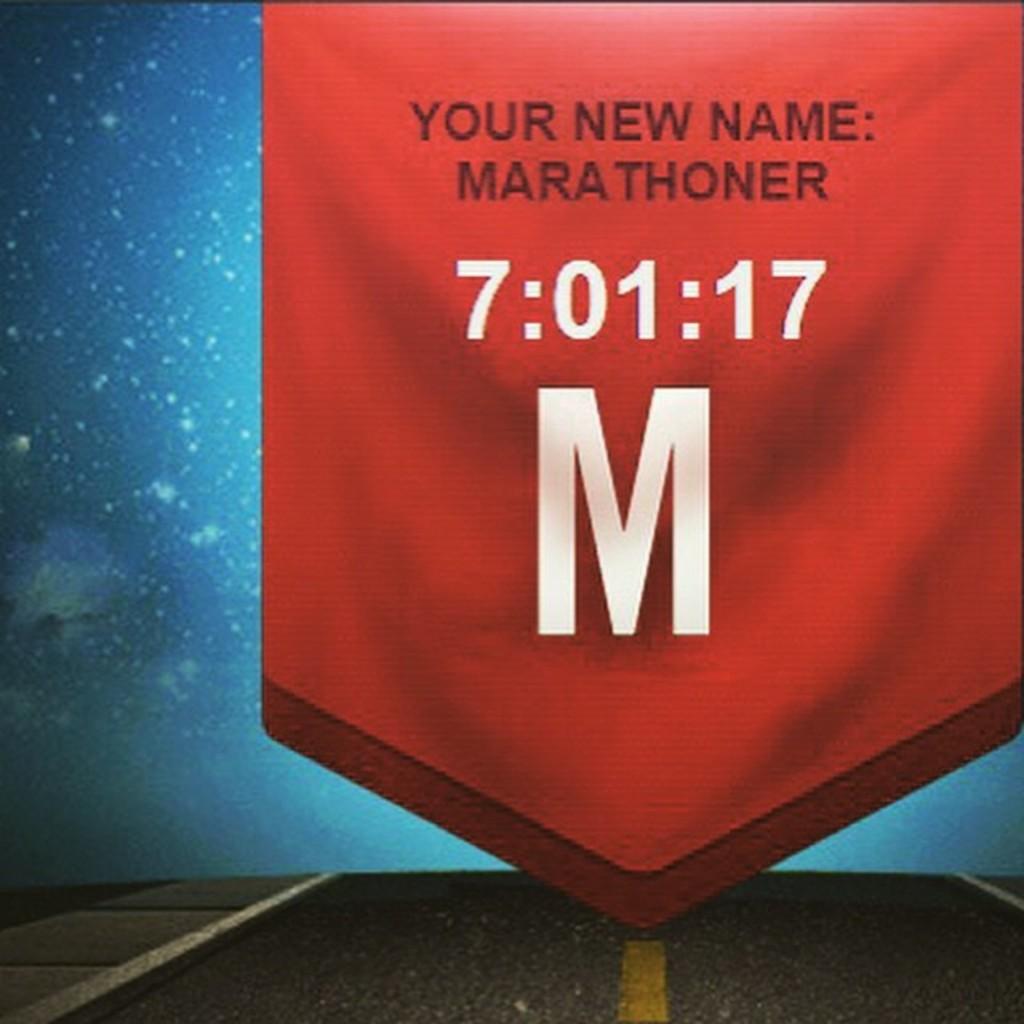What is your new name?
Provide a short and direct response. Marathoner. What is the large white letter on the banner?
Offer a terse response. M. 